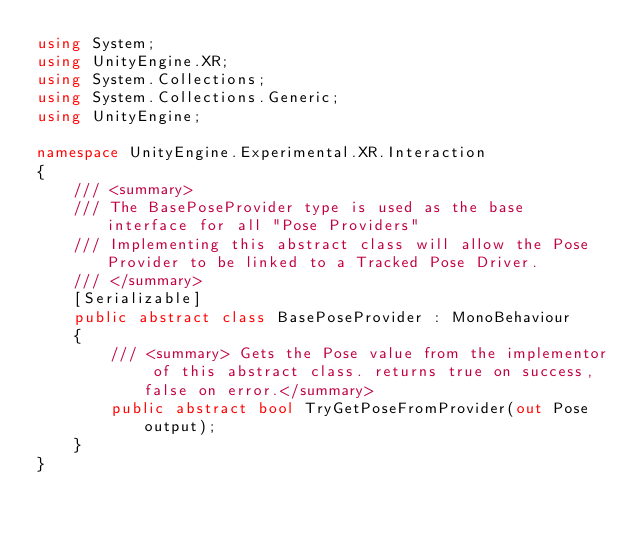Convert code to text. <code><loc_0><loc_0><loc_500><loc_500><_C#_>using System;
using UnityEngine.XR;
using System.Collections;
using System.Collections.Generic;
using UnityEngine;

namespace UnityEngine.Experimental.XR.Interaction
{
    /// <summary>
    /// The BasePoseProvider type is used as the base interface for all "Pose Providers"
    /// Implementing this abstract class will allow the Pose Provider to be linked to a Tracked Pose Driver.
    /// </summary>
    [Serializable]
    public abstract class BasePoseProvider : MonoBehaviour
    {
        /// <summary> Gets the Pose value from the implementor of this abstract class. returns true on success, false on error.</summary>
        public abstract bool TryGetPoseFromProvider(out Pose output);
    }
}
</code> 